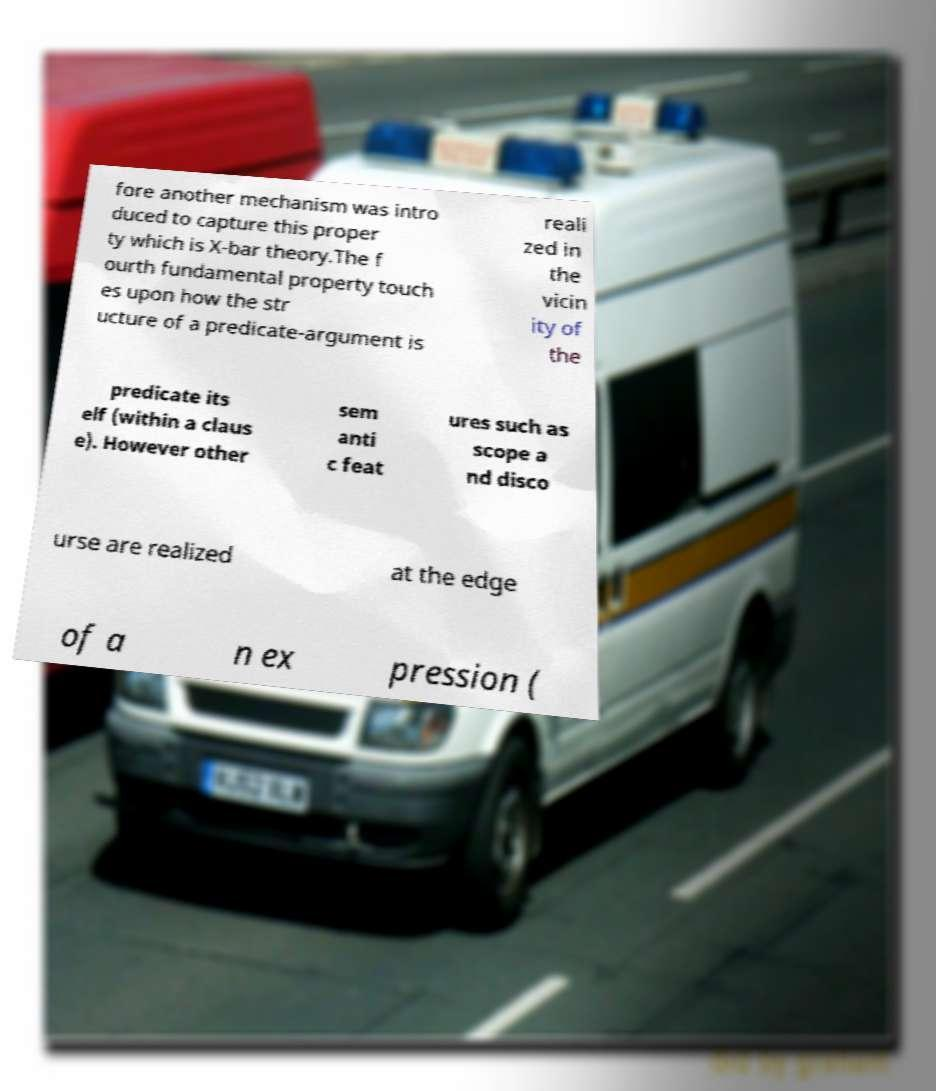Please identify and transcribe the text found in this image. fore another mechanism was intro duced to capture this proper ty which is X-bar theory.The f ourth fundamental property touch es upon how the str ucture of a predicate-argument is reali zed in the vicin ity of the predicate its elf (within a claus e). However other sem anti c feat ures such as scope a nd disco urse are realized at the edge of a n ex pression ( 